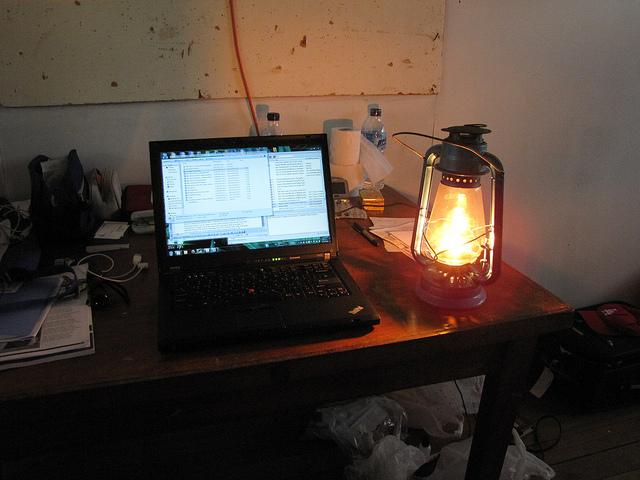What type of light source is next to the laptop? lantern 